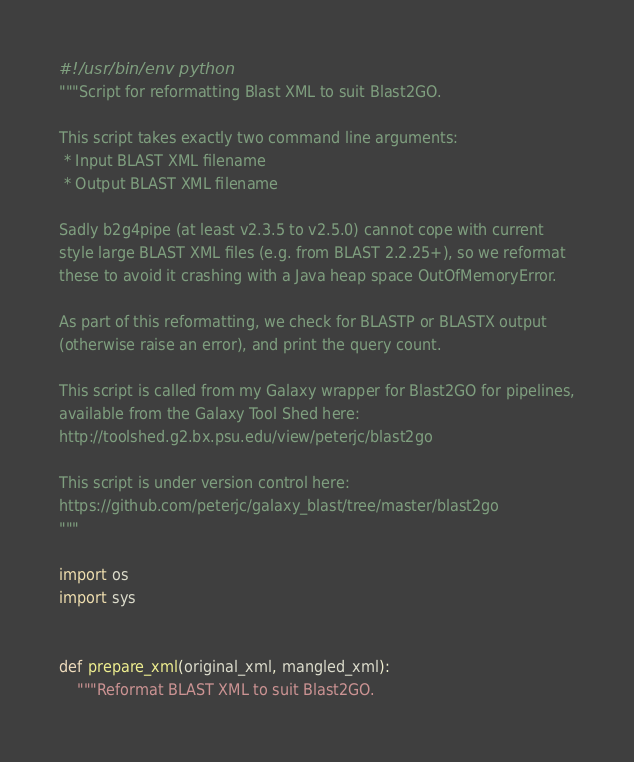<code> <loc_0><loc_0><loc_500><loc_500><_Python_>#!/usr/bin/env python
"""Script for reformatting Blast XML to suit Blast2GO.

This script takes exactly two command line arguments:
 * Input BLAST XML filename
 * Output BLAST XML filename

Sadly b2g4pipe (at least v2.3.5 to v2.5.0) cannot cope with current
style large BLAST XML files (e.g. from BLAST 2.2.25+), so we reformat
these to avoid it crashing with a Java heap space OutOfMemoryError.

As part of this reformatting, we check for BLASTP or BLASTX output
(otherwise raise an error), and print the query count.

This script is called from my Galaxy wrapper for Blast2GO for pipelines,
available from the Galaxy Tool Shed here:
http://toolshed.g2.bx.psu.edu/view/peterjc/blast2go

This script is under version control here:
https://github.com/peterjc/galaxy_blast/tree/master/blast2go
"""

import os
import sys


def prepare_xml(original_xml, mangled_xml):
    """Reformat BLAST XML to suit Blast2GO.
</code> 